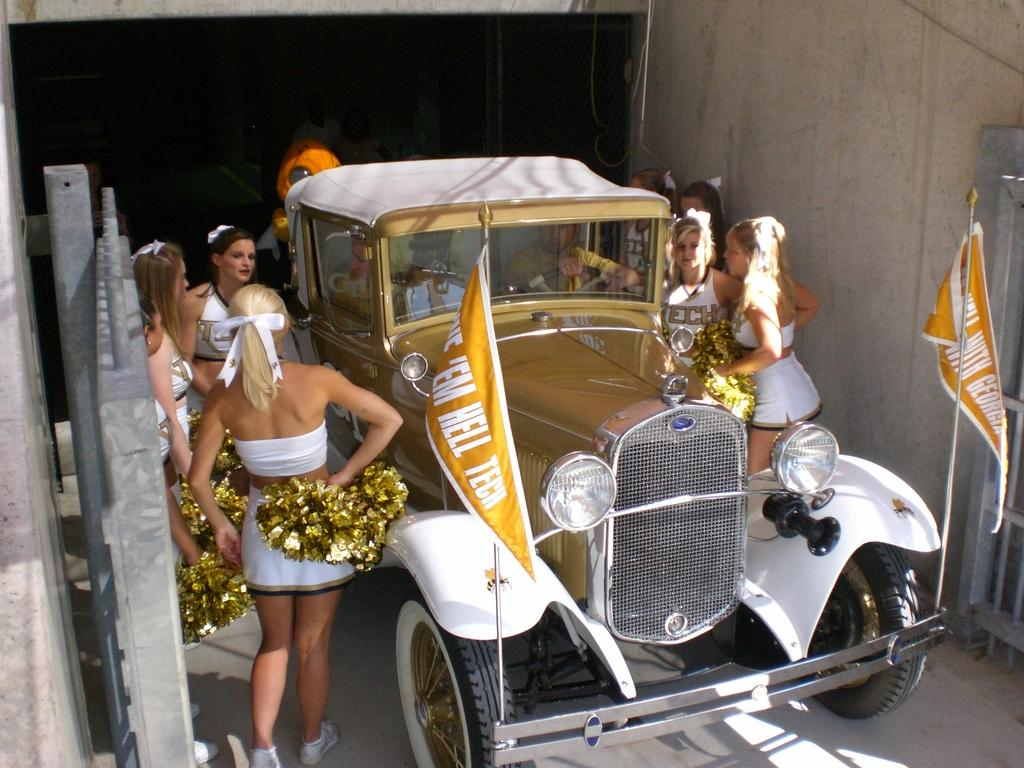What is the main subject of the image? The main subject of the image is a car. What are the girls doing in the image? The girls are standing around the car. What type of structure can be seen in the background of the image? There is an iron gate in the image. How does the car's design increase the girls' mindset in the image? There is no information in the image about the car's design or its effect on the girls' mindset. 